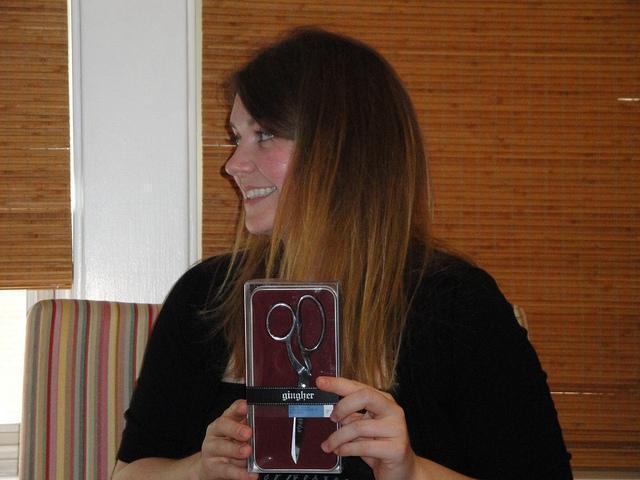What is the design of the chair?
Choose the correct response and explain in the format: 'Answer: answer
Rationale: rationale.'
Options: Dotted, striped, checkered, solid. Answer: striped.
Rationale: It has lines going vertical and different colors. 